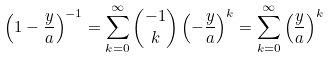Convert formula to latex. <formula><loc_0><loc_0><loc_500><loc_500>\left ( 1 - \frac { y } { a } \right ) ^ { - 1 } = \sum _ { k = 0 } ^ { \infty } { - 1 \choose k } \left ( - \frac { y } { a } \right ) ^ { k } = \sum _ { k = 0 } ^ { \infty } \left ( \frac { y } { a } \right ) ^ { k }</formula> 